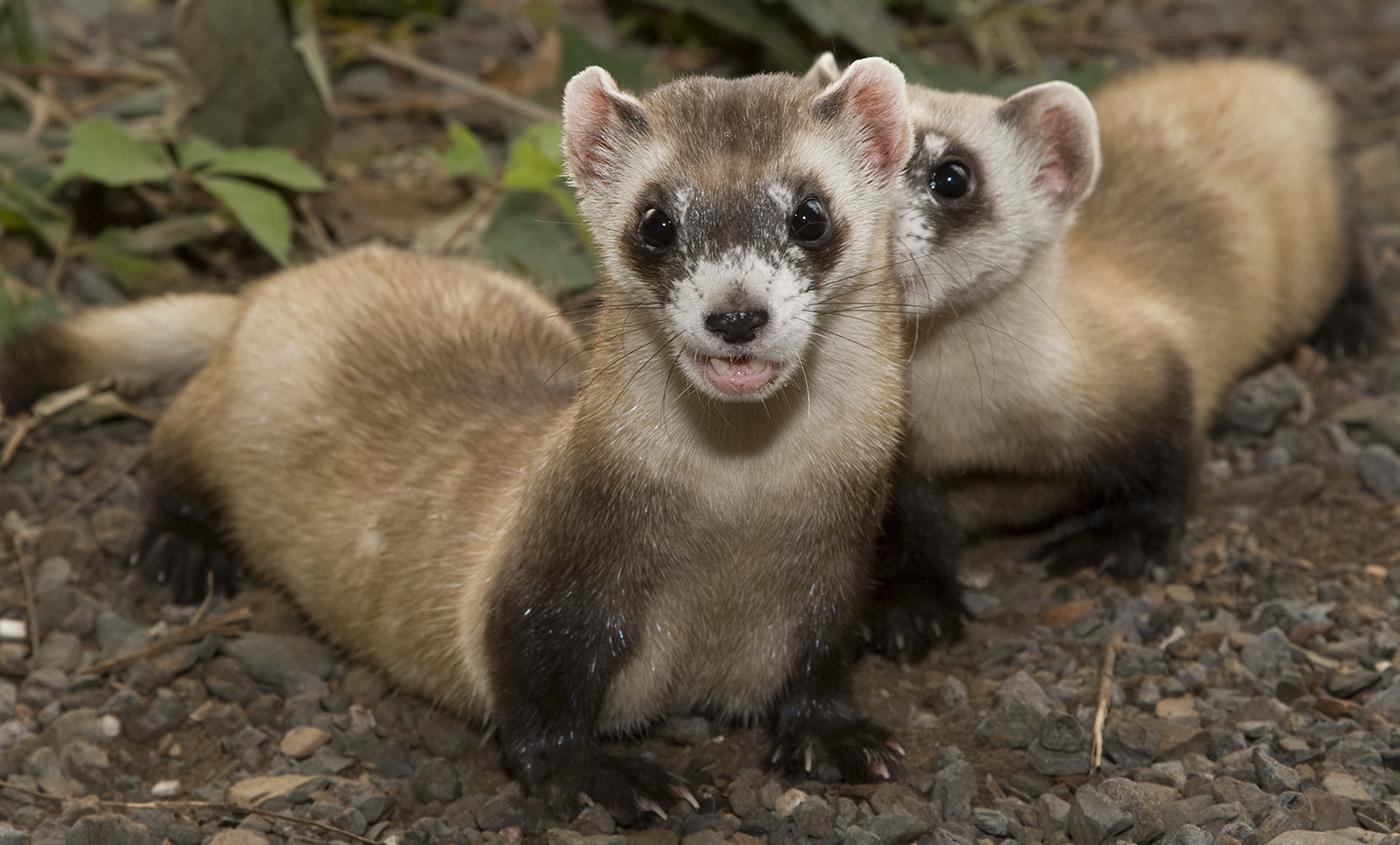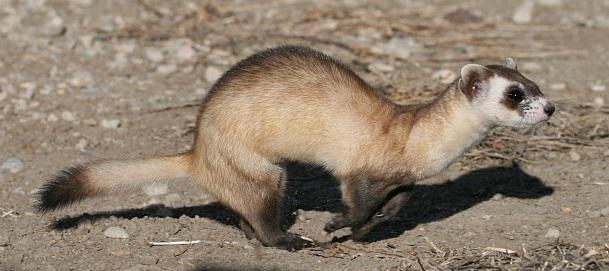The first image is the image on the left, the second image is the image on the right. Considering the images on both sides, is "A total of two ferrets are shown, each of them fully above ground." valid? Answer yes or no. No. The first image is the image on the left, the second image is the image on the right. Given the left and right images, does the statement "The animal in the image on the right is holding one paw off the ground." hold true? Answer yes or no. Yes. 